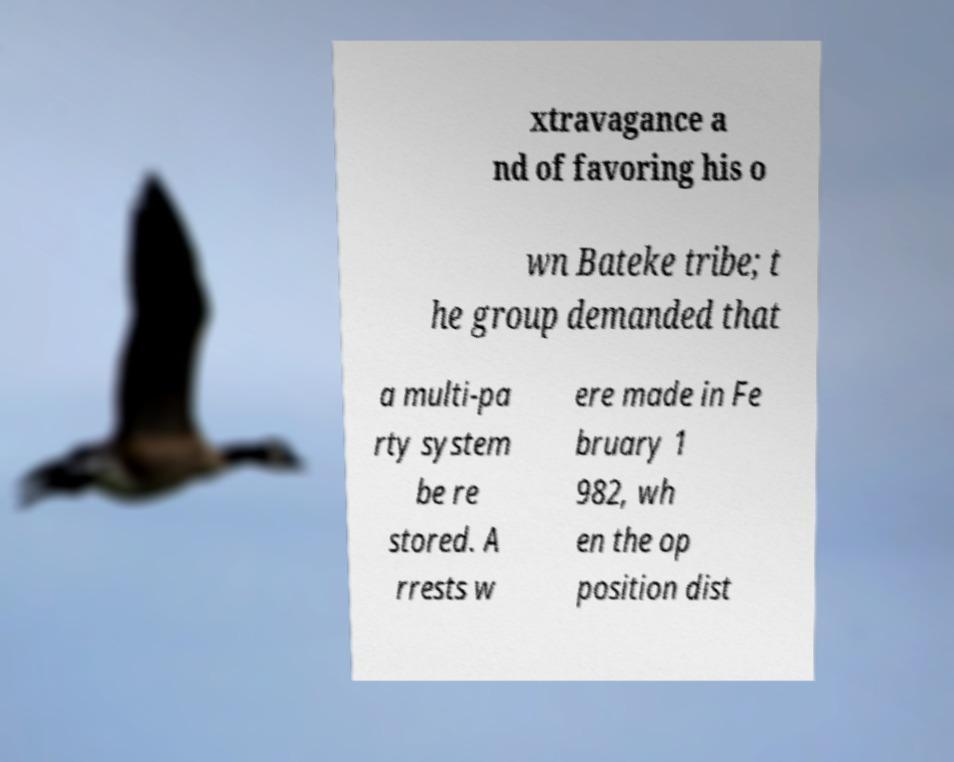Please identify and transcribe the text found in this image. xtravagance a nd of favoring his o wn Bateke tribe; t he group demanded that a multi-pa rty system be re stored. A rrests w ere made in Fe bruary 1 982, wh en the op position dist 